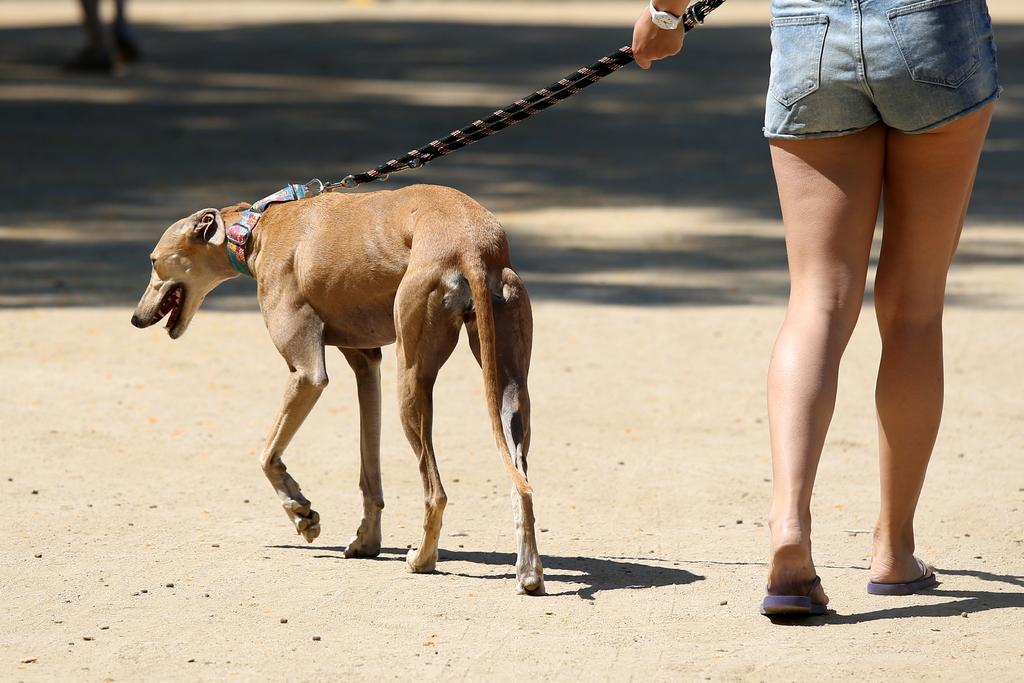Could you give a brief overview of what you see in this image? This picture shows a woman holding a dog with the help of a string and walking. The dog is brown in color and we see another human walking. 